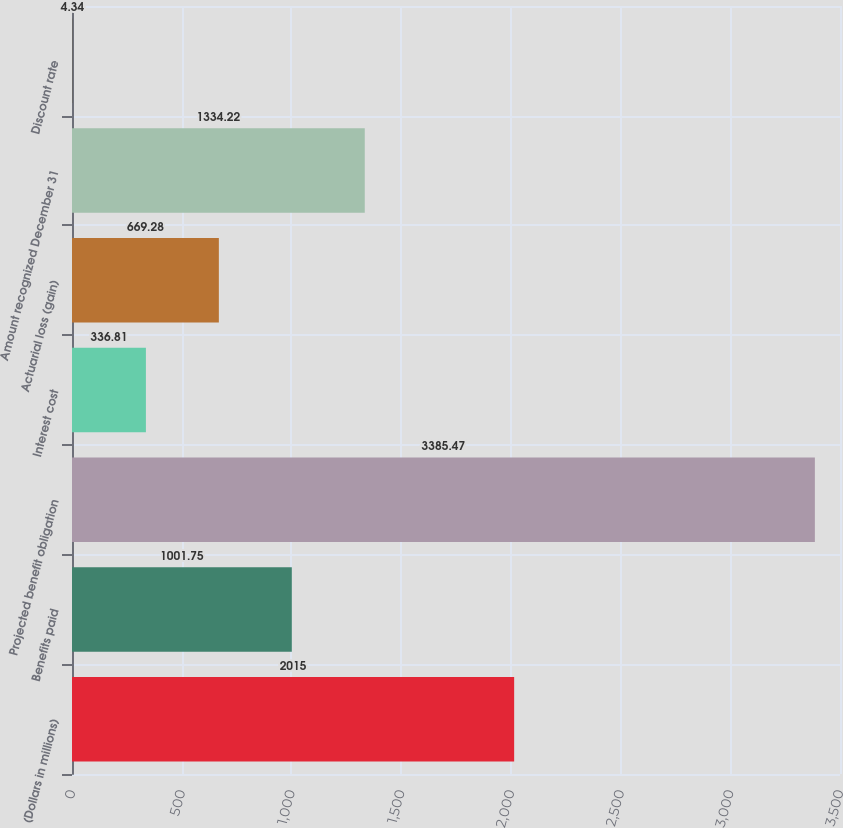Convert chart. <chart><loc_0><loc_0><loc_500><loc_500><bar_chart><fcel>(Dollars in millions)<fcel>Benefits paid<fcel>Projected benefit obligation<fcel>Interest cost<fcel>Actuarial loss (gain)<fcel>Amount recognized December 31<fcel>Discount rate<nl><fcel>2015<fcel>1001.75<fcel>3385.47<fcel>336.81<fcel>669.28<fcel>1334.22<fcel>4.34<nl></chart> 